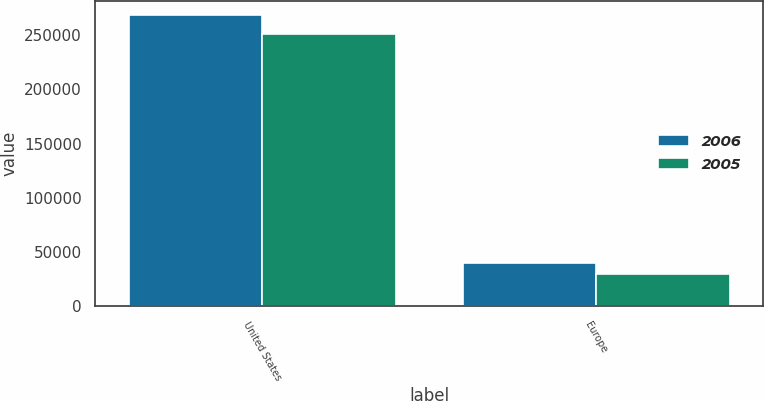Convert chart. <chart><loc_0><loc_0><loc_500><loc_500><stacked_bar_chart><ecel><fcel>United States<fcel>Europe<nl><fcel>2006<fcel>268313<fcel>39678<nl><fcel>2005<fcel>250430<fcel>29996<nl></chart> 